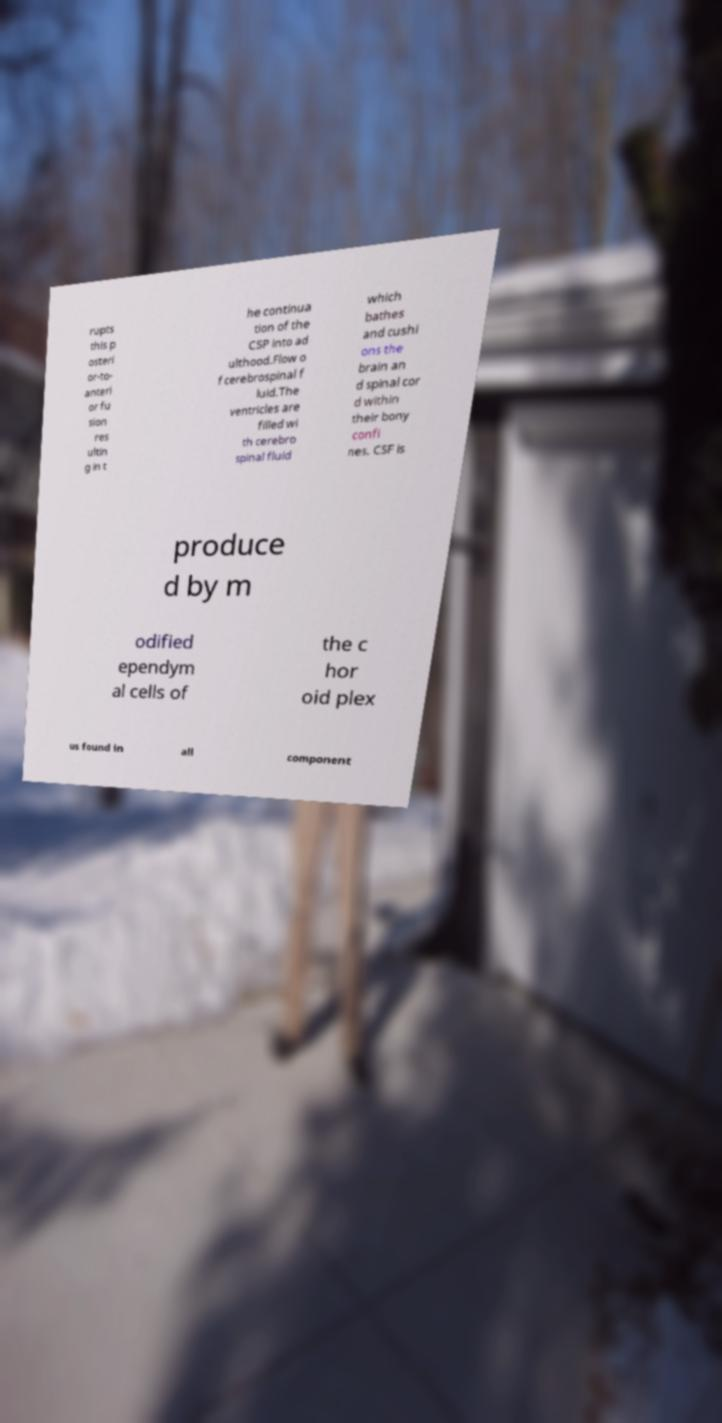Could you assist in decoding the text presented in this image and type it out clearly? rupts this p osteri or-to- anteri or fu sion res ultin g in t he continua tion of the CSP into ad ulthood.Flow o f cerebrospinal f luid.The ventricles are filled wi th cerebro spinal fluid which bathes and cushi ons the brain an d spinal cor d within their bony confi nes. CSF is produce d by m odified ependym al cells of the c hor oid plex us found in all component 